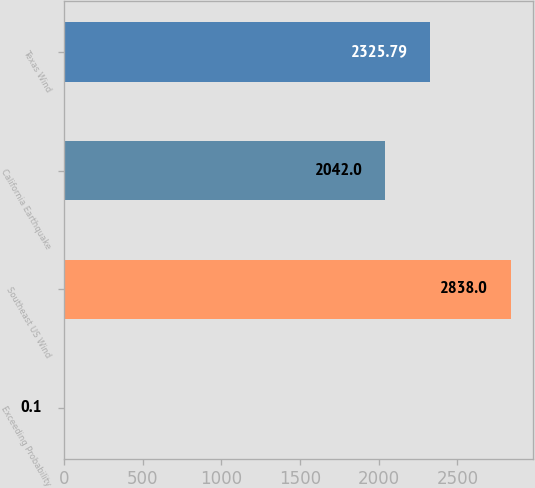Convert chart to OTSL. <chart><loc_0><loc_0><loc_500><loc_500><bar_chart><fcel>Exceeding Probability<fcel>Southeast US Wind<fcel>California Earthquake<fcel>Texas Wind<nl><fcel>0.1<fcel>2838<fcel>2042<fcel>2325.79<nl></chart> 